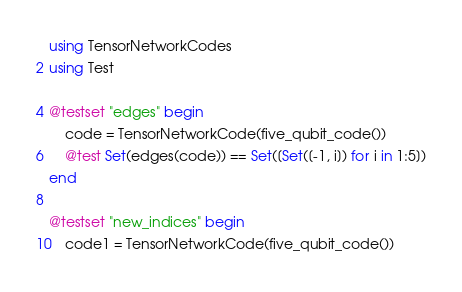Convert code to text. <code><loc_0><loc_0><loc_500><loc_500><_Julia_>using TensorNetworkCodes
using Test

@testset "edges" begin
    code = TensorNetworkCode(five_qubit_code())
    @test Set(edges(code)) == Set([Set([-1, i]) for i in 1:5])
end

@testset "new_indices" begin
    code1 = TensorNetworkCode(five_qubit_code())</code> 